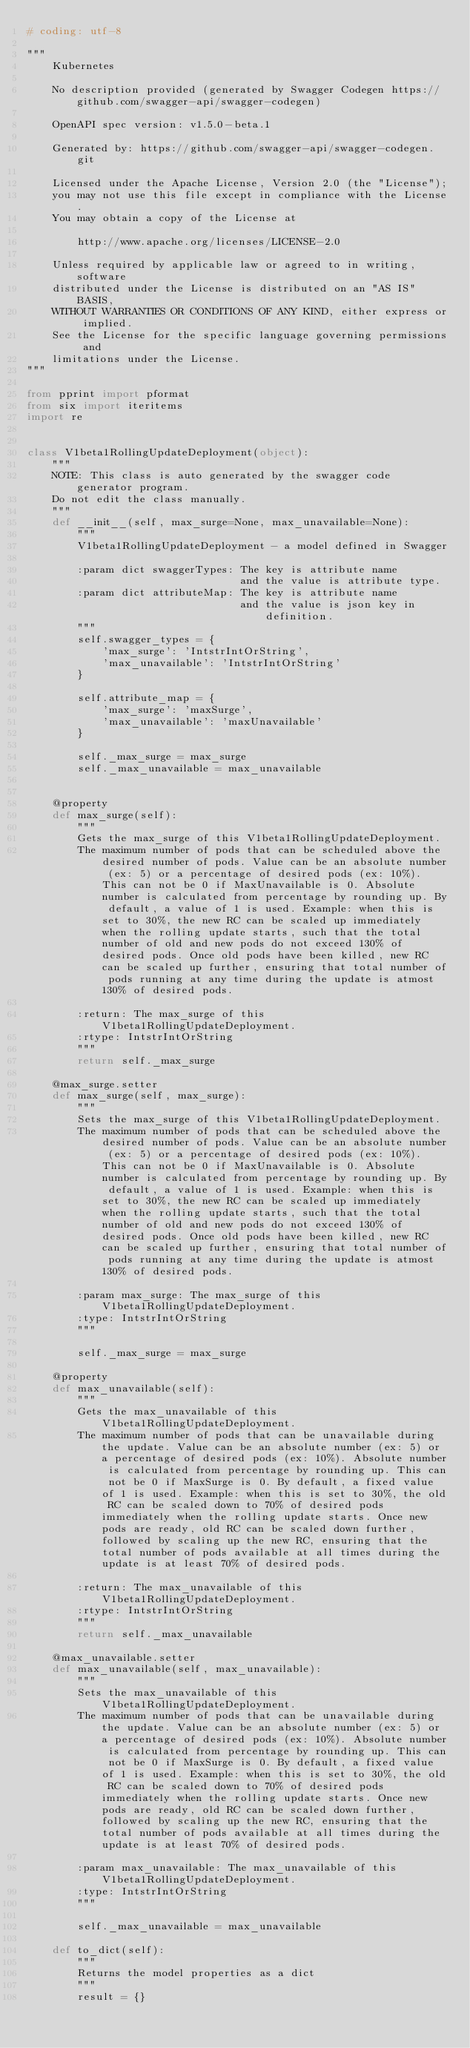<code> <loc_0><loc_0><loc_500><loc_500><_Python_># coding: utf-8

"""
    Kubernetes

    No description provided (generated by Swagger Codegen https://github.com/swagger-api/swagger-codegen)

    OpenAPI spec version: v1.5.0-beta.1
    
    Generated by: https://github.com/swagger-api/swagger-codegen.git

    Licensed under the Apache License, Version 2.0 (the "License");
    you may not use this file except in compliance with the License.
    You may obtain a copy of the License at

        http://www.apache.org/licenses/LICENSE-2.0

    Unless required by applicable law or agreed to in writing, software
    distributed under the License is distributed on an "AS IS" BASIS,
    WITHOUT WARRANTIES OR CONDITIONS OF ANY KIND, either express or implied.
    See the License for the specific language governing permissions and
    limitations under the License.
"""

from pprint import pformat
from six import iteritems
import re


class V1beta1RollingUpdateDeployment(object):
    """
    NOTE: This class is auto generated by the swagger code generator program.
    Do not edit the class manually.
    """
    def __init__(self, max_surge=None, max_unavailable=None):
        """
        V1beta1RollingUpdateDeployment - a model defined in Swagger

        :param dict swaggerTypes: The key is attribute name
                                  and the value is attribute type.
        :param dict attributeMap: The key is attribute name
                                  and the value is json key in definition.
        """
        self.swagger_types = {
            'max_surge': 'IntstrIntOrString',
            'max_unavailable': 'IntstrIntOrString'
        }

        self.attribute_map = {
            'max_surge': 'maxSurge',
            'max_unavailable': 'maxUnavailable'
        }

        self._max_surge = max_surge
        self._max_unavailable = max_unavailable


    @property
    def max_surge(self):
        """
        Gets the max_surge of this V1beta1RollingUpdateDeployment.
        The maximum number of pods that can be scheduled above the desired number of pods. Value can be an absolute number (ex: 5) or a percentage of desired pods (ex: 10%). This can not be 0 if MaxUnavailable is 0. Absolute number is calculated from percentage by rounding up. By default, a value of 1 is used. Example: when this is set to 30%, the new RC can be scaled up immediately when the rolling update starts, such that the total number of old and new pods do not exceed 130% of desired pods. Once old pods have been killed, new RC can be scaled up further, ensuring that total number of pods running at any time during the update is atmost 130% of desired pods.

        :return: The max_surge of this V1beta1RollingUpdateDeployment.
        :rtype: IntstrIntOrString
        """
        return self._max_surge

    @max_surge.setter
    def max_surge(self, max_surge):
        """
        Sets the max_surge of this V1beta1RollingUpdateDeployment.
        The maximum number of pods that can be scheduled above the desired number of pods. Value can be an absolute number (ex: 5) or a percentage of desired pods (ex: 10%). This can not be 0 if MaxUnavailable is 0. Absolute number is calculated from percentage by rounding up. By default, a value of 1 is used. Example: when this is set to 30%, the new RC can be scaled up immediately when the rolling update starts, such that the total number of old and new pods do not exceed 130% of desired pods. Once old pods have been killed, new RC can be scaled up further, ensuring that total number of pods running at any time during the update is atmost 130% of desired pods.

        :param max_surge: The max_surge of this V1beta1RollingUpdateDeployment.
        :type: IntstrIntOrString
        """

        self._max_surge = max_surge

    @property
    def max_unavailable(self):
        """
        Gets the max_unavailable of this V1beta1RollingUpdateDeployment.
        The maximum number of pods that can be unavailable during the update. Value can be an absolute number (ex: 5) or a percentage of desired pods (ex: 10%). Absolute number is calculated from percentage by rounding up. This can not be 0 if MaxSurge is 0. By default, a fixed value of 1 is used. Example: when this is set to 30%, the old RC can be scaled down to 70% of desired pods immediately when the rolling update starts. Once new pods are ready, old RC can be scaled down further, followed by scaling up the new RC, ensuring that the total number of pods available at all times during the update is at least 70% of desired pods.

        :return: The max_unavailable of this V1beta1RollingUpdateDeployment.
        :rtype: IntstrIntOrString
        """
        return self._max_unavailable

    @max_unavailable.setter
    def max_unavailable(self, max_unavailable):
        """
        Sets the max_unavailable of this V1beta1RollingUpdateDeployment.
        The maximum number of pods that can be unavailable during the update. Value can be an absolute number (ex: 5) or a percentage of desired pods (ex: 10%). Absolute number is calculated from percentage by rounding up. This can not be 0 if MaxSurge is 0. By default, a fixed value of 1 is used. Example: when this is set to 30%, the old RC can be scaled down to 70% of desired pods immediately when the rolling update starts. Once new pods are ready, old RC can be scaled down further, followed by scaling up the new RC, ensuring that the total number of pods available at all times during the update is at least 70% of desired pods.

        :param max_unavailable: The max_unavailable of this V1beta1RollingUpdateDeployment.
        :type: IntstrIntOrString
        """

        self._max_unavailable = max_unavailable

    def to_dict(self):
        """
        Returns the model properties as a dict
        """
        result = {}
</code> 